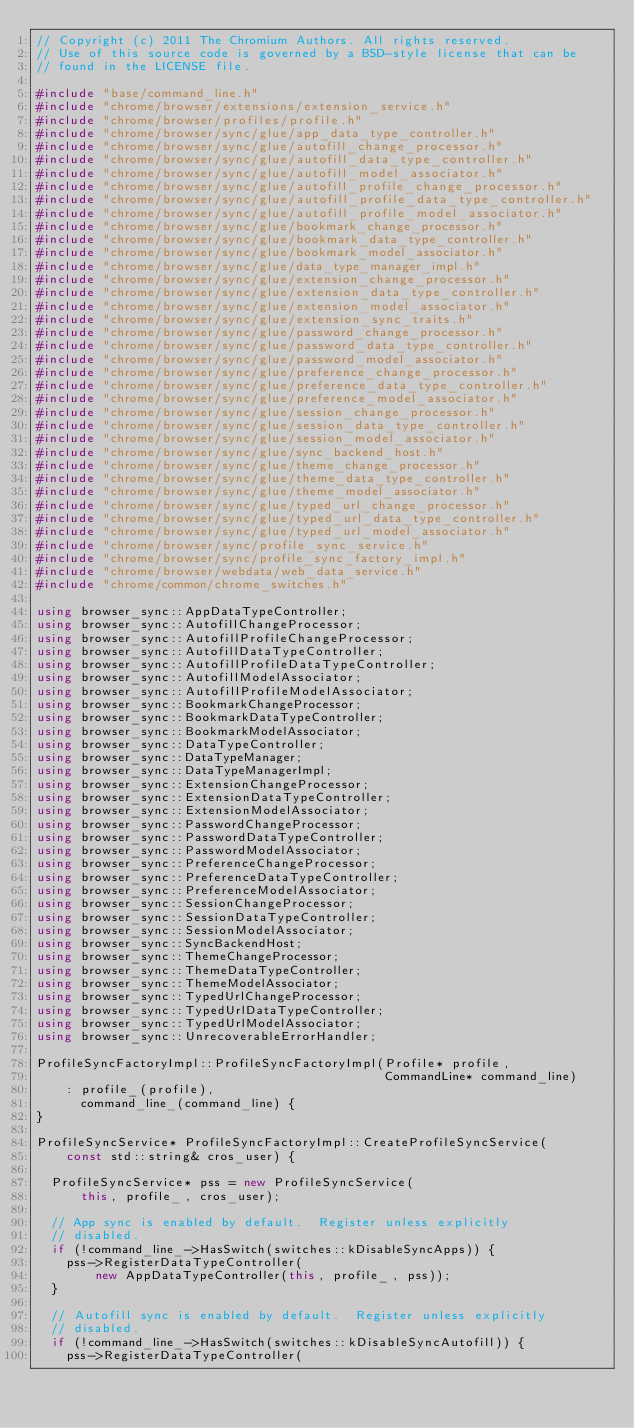<code> <loc_0><loc_0><loc_500><loc_500><_C++_>// Copyright (c) 2011 The Chromium Authors. All rights reserved.
// Use of this source code is governed by a BSD-style license that can be
// found in the LICENSE file.

#include "base/command_line.h"
#include "chrome/browser/extensions/extension_service.h"
#include "chrome/browser/profiles/profile.h"
#include "chrome/browser/sync/glue/app_data_type_controller.h"
#include "chrome/browser/sync/glue/autofill_change_processor.h"
#include "chrome/browser/sync/glue/autofill_data_type_controller.h"
#include "chrome/browser/sync/glue/autofill_model_associator.h"
#include "chrome/browser/sync/glue/autofill_profile_change_processor.h"
#include "chrome/browser/sync/glue/autofill_profile_data_type_controller.h"
#include "chrome/browser/sync/glue/autofill_profile_model_associator.h"
#include "chrome/browser/sync/glue/bookmark_change_processor.h"
#include "chrome/browser/sync/glue/bookmark_data_type_controller.h"
#include "chrome/browser/sync/glue/bookmark_model_associator.h"
#include "chrome/browser/sync/glue/data_type_manager_impl.h"
#include "chrome/browser/sync/glue/extension_change_processor.h"
#include "chrome/browser/sync/glue/extension_data_type_controller.h"
#include "chrome/browser/sync/glue/extension_model_associator.h"
#include "chrome/browser/sync/glue/extension_sync_traits.h"
#include "chrome/browser/sync/glue/password_change_processor.h"
#include "chrome/browser/sync/glue/password_data_type_controller.h"
#include "chrome/browser/sync/glue/password_model_associator.h"
#include "chrome/browser/sync/glue/preference_change_processor.h"
#include "chrome/browser/sync/glue/preference_data_type_controller.h"
#include "chrome/browser/sync/glue/preference_model_associator.h"
#include "chrome/browser/sync/glue/session_change_processor.h"
#include "chrome/browser/sync/glue/session_data_type_controller.h"
#include "chrome/browser/sync/glue/session_model_associator.h"
#include "chrome/browser/sync/glue/sync_backend_host.h"
#include "chrome/browser/sync/glue/theme_change_processor.h"
#include "chrome/browser/sync/glue/theme_data_type_controller.h"
#include "chrome/browser/sync/glue/theme_model_associator.h"
#include "chrome/browser/sync/glue/typed_url_change_processor.h"
#include "chrome/browser/sync/glue/typed_url_data_type_controller.h"
#include "chrome/browser/sync/glue/typed_url_model_associator.h"
#include "chrome/browser/sync/profile_sync_service.h"
#include "chrome/browser/sync/profile_sync_factory_impl.h"
#include "chrome/browser/webdata/web_data_service.h"
#include "chrome/common/chrome_switches.h"

using browser_sync::AppDataTypeController;
using browser_sync::AutofillChangeProcessor;
using browser_sync::AutofillProfileChangeProcessor;
using browser_sync::AutofillDataTypeController;
using browser_sync::AutofillProfileDataTypeController;
using browser_sync::AutofillModelAssociator;
using browser_sync::AutofillProfileModelAssociator;
using browser_sync::BookmarkChangeProcessor;
using browser_sync::BookmarkDataTypeController;
using browser_sync::BookmarkModelAssociator;
using browser_sync::DataTypeController;
using browser_sync::DataTypeManager;
using browser_sync::DataTypeManagerImpl;
using browser_sync::ExtensionChangeProcessor;
using browser_sync::ExtensionDataTypeController;
using browser_sync::ExtensionModelAssociator;
using browser_sync::PasswordChangeProcessor;
using browser_sync::PasswordDataTypeController;
using browser_sync::PasswordModelAssociator;
using browser_sync::PreferenceChangeProcessor;
using browser_sync::PreferenceDataTypeController;
using browser_sync::PreferenceModelAssociator;
using browser_sync::SessionChangeProcessor;
using browser_sync::SessionDataTypeController;
using browser_sync::SessionModelAssociator;
using browser_sync::SyncBackendHost;
using browser_sync::ThemeChangeProcessor;
using browser_sync::ThemeDataTypeController;
using browser_sync::ThemeModelAssociator;
using browser_sync::TypedUrlChangeProcessor;
using browser_sync::TypedUrlDataTypeController;
using browser_sync::TypedUrlModelAssociator;
using browser_sync::UnrecoverableErrorHandler;

ProfileSyncFactoryImpl::ProfileSyncFactoryImpl(Profile* profile,
                                               CommandLine* command_line)
    : profile_(profile),
      command_line_(command_line) {
}

ProfileSyncService* ProfileSyncFactoryImpl::CreateProfileSyncService(
    const std::string& cros_user) {

  ProfileSyncService* pss = new ProfileSyncService(
      this, profile_, cros_user);

  // App sync is enabled by default.  Register unless explicitly
  // disabled.
  if (!command_line_->HasSwitch(switches::kDisableSyncApps)) {
    pss->RegisterDataTypeController(
        new AppDataTypeController(this, profile_, pss));
  }

  // Autofill sync is enabled by default.  Register unless explicitly
  // disabled.
  if (!command_line_->HasSwitch(switches::kDisableSyncAutofill)) {
    pss->RegisterDataTypeController(</code> 